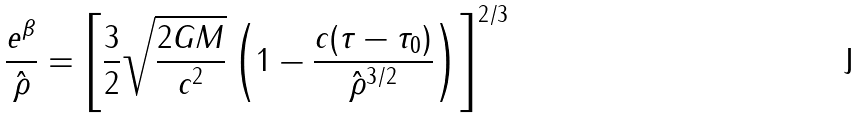Convert formula to latex. <formula><loc_0><loc_0><loc_500><loc_500>\frac { e ^ { \beta } } { \hat { \rho } } = \left [ \frac { 3 } { 2 } \sqrt { \frac { 2 G M } { c ^ { 2 } } } \left ( 1 - \frac { c ( \tau - \tau _ { 0 } ) } { \hat { \rho } ^ { 3 / 2 } } \right ) \right ] ^ { 2 / 3 }</formula> 